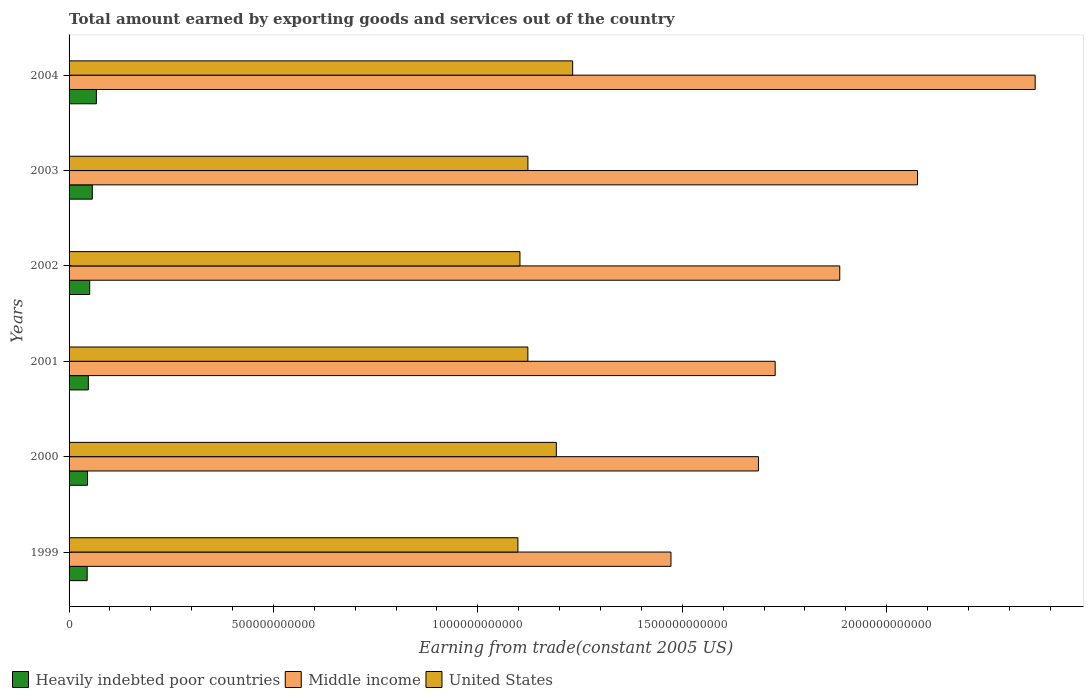How many different coloured bars are there?
Provide a short and direct response. 3. Are the number of bars on each tick of the Y-axis equal?
Your response must be concise. Yes. How many bars are there on the 3rd tick from the top?
Offer a terse response. 3. How many bars are there on the 6th tick from the bottom?
Keep it short and to the point. 3. In how many cases, is the number of bars for a given year not equal to the number of legend labels?
Ensure brevity in your answer.  0. What is the total amount earned by exporting goods and services in United States in 2003?
Your response must be concise. 1.12e+12. Across all years, what is the maximum total amount earned by exporting goods and services in Heavily indebted poor countries?
Offer a terse response. 6.68e+1. Across all years, what is the minimum total amount earned by exporting goods and services in Heavily indebted poor countries?
Provide a short and direct response. 4.43e+1. In which year was the total amount earned by exporting goods and services in Heavily indebted poor countries maximum?
Offer a very short reply. 2004. In which year was the total amount earned by exporting goods and services in Heavily indebted poor countries minimum?
Offer a very short reply. 1999. What is the total total amount earned by exporting goods and services in Heavily indebted poor countries in the graph?
Your response must be concise. 3.11e+11. What is the difference between the total amount earned by exporting goods and services in Heavily indebted poor countries in 1999 and that in 2002?
Keep it short and to the point. -6.18e+09. What is the difference between the total amount earned by exporting goods and services in Middle income in 1999 and the total amount earned by exporting goods and services in Heavily indebted poor countries in 2002?
Your response must be concise. 1.42e+12. What is the average total amount earned by exporting goods and services in Heavily indebted poor countries per year?
Make the answer very short. 5.18e+1. In the year 2000, what is the difference between the total amount earned by exporting goods and services in United States and total amount earned by exporting goods and services in Heavily indebted poor countries?
Offer a very short reply. 1.15e+12. In how many years, is the total amount earned by exporting goods and services in Middle income greater than 1400000000000 US$?
Ensure brevity in your answer.  6. What is the ratio of the total amount earned by exporting goods and services in United States in 1999 to that in 2003?
Offer a very short reply. 0.98. Is the total amount earned by exporting goods and services in Heavily indebted poor countries in 2000 less than that in 2001?
Provide a short and direct response. Yes. Is the difference between the total amount earned by exporting goods and services in United States in 2001 and 2004 greater than the difference between the total amount earned by exporting goods and services in Heavily indebted poor countries in 2001 and 2004?
Your answer should be compact. No. What is the difference between the highest and the second highest total amount earned by exporting goods and services in Heavily indebted poor countries?
Provide a succinct answer. 9.96e+09. What is the difference between the highest and the lowest total amount earned by exporting goods and services in Middle income?
Your answer should be very brief. 8.91e+11. Is the sum of the total amount earned by exporting goods and services in United States in 2000 and 2002 greater than the maximum total amount earned by exporting goods and services in Heavily indebted poor countries across all years?
Keep it short and to the point. Yes. What does the 3rd bar from the top in 2001 represents?
Provide a succinct answer. Heavily indebted poor countries. What does the 3rd bar from the bottom in 2003 represents?
Give a very brief answer. United States. How many bars are there?
Offer a terse response. 18. How many years are there in the graph?
Your answer should be very brief. 6. What is the difference between two consecutive major ticks on the X-axis?
Provide a succinct answer. 5.00e+11. Where does the legend appear in the graph?
Make the answer very short. Bottom left. How are the legend labels stacked?
Your answer should be compact. Horizontal. What is the title of the graph?
Ensure brevity in your answer.  Total amount earned by exporting goods and services out of the country. Does "Northern Mariana Islands" appear as one of the legend labels in the graph?
Provide a short and direct response. No. What is the label or title of the X-axis?
Give a very brief answer. Earning from trade(constant 2005 US). What is the Earning from trade(constant 2005 US) of Heavily indebted poor countries in 1999?
Your answer should be very brief. 4.43e+1. What is the Earning from trade(constant 2005 US) of Middle income in 1999?
Your answer should be very brief. 1.47e+12. What is the Earning from trade(constant 2005 US) of United States in 1999?
Give a very brief answer. 1.10e+12. What is the Earning from trade(constant 2005 US) of Heavily indebted poor countries in 2000?
Give a very brief answer. 4.51e+1. What is the Earning from trade(constant 2005 US) of Middle income in 2000?
Make the answer very short. 1.69e+12. What is the Earning from trade(constant 2005 US) in United States in 2000?
Keep it short and to the point. 1.19e+12. What is the Earning from trade(constant 2005 US) in Heavily indebted poor countries in 2001?
Your answer should be compact. 4.71e+1. What is the Earning from trade(constant 2005 US) of Middle income in 2001?
Your answer should be very brief. 1.73e+12. What is the Earning from trade(constant 2005 US) of United States in 2001?
Offer a terse response. 1.12e+12. What is the Earning from trade(constant 2005 US) in Heavily indebted poor countries in 2002?
Provide a succinct answer. 5.05e+1. What is the Earning from trade(constant 2005 US) of Middle income in 2002?
Make the answer very short. 1.89e+12. What is the Earning from trade(constant 2005 US) of United States in 2002?
Provide a succinct answer. 1.10e+12. What is the Earning from trade(constant 2005 US) in Heavily indebted poor countries in 2003?
Your answer should be compact. 5.68e+1. What is the Earning from trade(constant 2005 US) of Middle income in 2003?
Offer a very short reply. 2.08e+12. What is the Earning from trade(constant 2005 US) in United States in 2003?
Ensure brevity in your answer.  1.12e+12. What is the Earning from trade(constant 2005 US) of Heavily indebted poor countries in 2004?
Offer a terse response. 6.68e+1. What is the Earning from trade(constant 2005 US) in Middle income in 2004?
Provide a short and direct response. 2.36e+12. What is the Earning from trade(constant 2005 US) in United States in 2004?
Provide a short and direct response. 1.23e+12. Across all years, what is the maximum Earning from trade(constant 2005 US) of Heavily indebted poor countries?
Give a very brief answer. 6.68e+1. Across all years, what is the maximum Earning from trade(constant 2005 US) in Middle income?
Your response must be concise. 2.36e+12. Across all years, what is the maximum Earning from trade(constant 2005 US) of United States?
Offer a terse response. 1.23e+12. Across all years, what is the minimum Earning from trade(constant 2005 US) of Heavily indebted poor countries?
Your response must be concise. 4.43e+1. Across all years, what is the minimum Earning from trade(constant 2005 US) of Middle income?
Your answer should be very brief. 1.47e+12. Across all years, what is the minimum Earning from trade(constant 2005 US) of United States?
Provide a short and direct response. 1.10e+12. What is the total Earning from trade(constant 2005 US) of Heavily indebted poor countries in the graph?
Ensure brevity in your answer.  3.11e+11. What is the total Earning from trade(constant 2005 US) in Middle income in the graph?
Offer a very short reply. 1.12e+13. What is the total Earning from trade(constant 2005 US) of United States in the graph?
Your response must be concise. 6.87e+12. What is the difference between the Earning from trade(constant 2005 US) of Heavily indebted poor countries in 1999 and that in 2000?
Your response must be concise. -7.91e+08. What is the difference between the Earning from trade(constant 2005 US) of Middle income in 1999 and that in 2000?
Offer a terse response. -2.14e+11. What is the difference between the Earning from trade(constant 2005 US) of United States in 1999 and that in 2000?
Make the answer very short. -9.40e+1. What is the difference between the Earning from trade(constant 2005 US) of Heavily indebted poor countries in 1999 and that in 2001?
Your answer should be compact. -2.83e+09. What is the difference between the Earning from trade(constant 2005 US) of Middle income in 1999 and that in 2001?
Provide a short and direct response. -2.55e+11. What is the difference between the Earning from trade(constant 2005 US) of United States in 1999 and that in 2001?
Provide a succinct answer. -2.44e+1. What is the difference between the Earning from trade(constant 2005 US) in Heavily indebted poor countries in 1999 and that in 2002?
Keep it short and to the point. -6.18e+09. What is the difference between the Earning from trade(constant 2005 US) of Middle income in 1999 and that in 2002?
Your answer should be compact. -4.13e+11. What is the difference between the Earning from trade(constant 2005 US) in United States in 1999 and that in 2002?
Provide a short and direct response. -5.04e+09. What is the difference between the Earning from trade(constant 2005 US) in Heavily indebted poor countries in 1999 and that in 2003?
Offer a terse response. -1.25e+1. What is the difference between the Earning from trade(constant 2005 US) in Middle income in 1999 and that in 2003?
Keep it short and to the point. -6.03e+11. What is the difference between the Earning from trade(constant 2005 US) in United States in 1999 and that in 2003?
Ensure brevity in your answer.  -2.45e+1. What is the difference between the Earning from trade(constant 2005 US) of Heavily indebted poor countries in 1999 and that in 2004?
Your response must be concise. -2.25e+1. What is the difference between the Earning from trade(constant 2005 US) of Middle income in 1999 and that in 2004?
Your answer should be compact. -8.91e+11. What is the difference between the Earning from trade(constant 2005 US) in United States in 1999 and that in 2004?
Keep it short and to the point. -1.34e+11. What is the difference between the Earning from trade(constant 2005 US) in Heavily indebted poor countries in 2000 and that in 2001?
Make the answer very short. -2.04e+09. What is the difference between the Earning from trade(constant 2005 US) of Middle income in 2000 and that in 2001?
Provide a succinct answer. -4.09e+1. What is the difference between the Earning from trade(constant 2005 US) of United States in 2000 and that in 2001?
Ensure brevity in your answer.  6.96e+1. What is the difference between the Earning from trade(constant 2005 US) in Heavily indebted poor countries in 2000 and that in 2002?
Provide a short and direct response. -5.38e+09. What is the difference between the Earning from trade(constant 2005 US) of Middle income in 2000 and that in 2002?
Offer a very short reply. -1.99e+11. What is the difference between the Earning from trade(constant 2005 US) of United States in 2000 and that in 2002?
Your answer should be compact. 8.90e+1. What is the difference between the Earning from trade(constant 2005 US) of Heavily indebted poor countries in 2000 and that in 2003?
Give a very brief answer. -1.17e+1. What is the difference between the Earning from trade(constant 2005 US) in Middle income in 2000 and that in 2003?
Provide a short and direct response. -3.89e+11. What is the difference between the Earning from trade(constant 2005 US) of United States in 2000 and that in 2003?
Offer a very short reply. 6.95e+1. What is the difference between the Earning from trade(constant 2005 US) of Heavily indebted poor countries in 2000 and that in 2004?
Your response must be concise. -2.17e+1. What is the difference between the Earning from trade(constant 2005 US) of Middle income in 2000 and that in 2004?
Make the answer very short. -6.77e+11. What is the difference between the Earning from trade(constant 2005 US) of United States in 2000 and that in 2004?
Ensure brevity in your answer.  -3.99e+1. What is the difference between the Earning from trade(constant 2005 US) in Heavily indebted poor countries in 2001 and that in 2002?
Your response must be concise. -3.34e+09. What is the difference between the Earning from trade(constant 2005 US) in Middle income in 2001 and that in 2002?
Your response must be concise. -1.58e+11. What is the difference between the Earning from trade(constant 2005 US) of United States in 2001 and that in 2002?
Offer a terse response. 1.94e+1. What is the difference between the Earning from trade(constant 2005 US) in Heavily indebted poor countries in 2001 and that in 2003?
Provide a short and direct response. -9.70e+09. What is the difference between the Earning from trade(constant 2005 US) of Middle income in 2001 and that in 2003?
Your answer should be very brief. -3.48e+11. What is the difference between the Earning from trade(constant 2005 US) of United States in 2001 and that in 2003?
Make the answer very short. -1.06e+08. What is the difference between the Earning from trade(constant 2005 US) in Heavily indebted poor countries in 2001 and that in 2004?
Your response must be concise. -1.97e+1. What is the difference between the Earning from trade(constant 2005 US) of Middle income in 2001 and that in 2004?
Offer a very short reply. -6.36e+11. What is the difference between the Earning from trade(constant 2005 US) in United States in 2001 and that in 2004?
Your response must be concise. -1.10e+11. What is the difference between the Earning from trade(constant 2005 US) of Heavily indebted poor countries in 2002 and that in 2003?
Keep it short and to the point. -6.36e+09. What is the difference between the Earning from trade(constant 2005 US) of Middle income in 2002 and that in 2003?
Your response must be concise. -1.90e+11. What is the difference between the Earning from trade(constant 2005 US) of United States in 2002 and that in 2003?
Ensure brevity in your answer.  -1.95e+1. What is the difference between the Earning from trade(constant 2005 US) of Heavily indebted poor countries in 2002 and that in 2004?
Give a very brief answer. -1.63e+1. What is the difference between the Earning from trade(constant 2005 US) in Middle income in 2002 and that in 2004?
Offer a very short reply. -4.78e+11. What is the difference between the Earning from trade(constant 2005 US) of United States in 2002 and that in 2004?
Ensure brevity in your answer.  -1.29e+11. What is the difference between the Earning from trade(constant 2005 US) in Heavily indebted poor countries in 2003 and that in 2004?
Give a very brief answer. -9.96e+09. What is the difference between the Earning from trade(constant 2005 US) of Middle income in 2003 and that in 2004?
Keep it short and to the point. -2.88e+11. What is the difference between the Earning from trade(constant 2005 US) in United States in 2003 and that in 2004?
Your answer should be very brief. -1.09e+11. What is the difference between the Earning from trade(constant 2005 US) in Heavily indebted poor countries in 1999 and the Earning from trade(constant 2005 US) in Middle income in 2000?
Offer a terse response. -1.64e+12. What is the difference between the Earning from trade(constant 2005 US) in Heavily indebted poor countries in 1999 and the Earning from trade(constant 2005 US) in United States in 2000?
Make the answer very short. -1.15e+12. What is the difference between the Earning from trade(constant 2005 US) of Middle income in 1999 and the Earning from trade(constant 2005 US) of United States in 2000?
Offer a terse response. 2.80e+11. What is the difference between the Earning from trade(constant 2005 US) in Heavily indebted poor countries in 1999 and the Earning from trade(constant 2005 US) in Middle income in 2001?
Give a very brief answer. -1.68e+12. What is the difference between the Earning from trade(constant 2005 US) in Heavily indebted poor countries in 1999 and the Earning from trade(constant 2005 US) in United States in 2001?
Provide a short and direct response. -1.08e+12. What is the difference between the Earning from trade(constant 2005 US) of Middle income in 1999 and the Earning from trade(constant 2005 US) of United States in 2001?
Offer a terse response. 3.50e+11. What is the difference between the Earning from trade(constant 2005 US) in Heavily indebted poor countries in 1999 and the Earning from trade(constant 2005 US) in Middle income in 2002?
Give a very brief answer. -1.84e+12. What is the difference between the Earning from trade(constant 2005 US) in Heavily indebted poor countries in 1999 and the Earning from trade(constant 2005 US) in United States in 2002?
Provide a succinct answer. -1.06e+12. What is the difference between the Earning from trade(constant 2005 US) in Middle income in 1999 and the Earning from trade(constant 2005 US) in United States in 2002?
Your response must be concise. 3.69e+11. What is the difference between the Earning from trade(constant 2005 US) in Heavily indebted poor countries in 1999 and the Earning from trade(constant 2005 US) in Middle income in 2003?
Give a very brief answer. -2.03e+12. What is the difference between the Earning from trade(constant 2005 US) in Heavily indebted poor countries in 1999 and the Earning from trade(constant 2005 US) in United States in 2003?
Offer a very short reply. -1.08e+12. What is the difference between the Earning from trade(constant 2005 US) in Middle income in 1999 and the Earning from trade(constant 2005 US) in United States in 2003?
Keep it short and to the point. 3.50e+11. What is the difference between the Earning from trade(constant 2005 US) in Heavily indebted poor countries in 1999 and the Earning from trade(constant 2005 US) in Middle income in 2004?
Your response must be concise. -2.32e+12. What is the difference between the Earning from trade(constant 2005 US) of Heavily indebted poor countries in 1999 and the Earning from trade(constant 2005 US) of United States in 2004?
Make the answer very short. -1.19e+12. What is the difference between the Earning from trade(constant 2005 US) in Middle income in 1999 and the Earning from trade(constant 2005 US) in United States in 2004?
Provide a succinct answer. 2.40e+11. What is the difference between the Earning from trade(constant 2005 US) in Heavily indebted poor countries in 2000 and the Earning from trade(constant 2005 US) in Middle income in 2001?
Ensure brevity in your answer.  -1.68e+12. What is the difference between the Earning from trade(constant 2005 US) of Heavily indebted poor countries in 2000 and the Earning from trade(constant 2005 US) of United States in 2001?
Your answer should be compact. -1.08e+12. What is the difference between the Earning from trade(constant 2005 US) of Middle income in 2000 and the Earning from trade(constant 2005 US) of United States in 2001?
Ensure brevity in your answer.  5.64e+11. What is the difference between the Earning from trade(constant 2005 US) of Heavily indebted poor countries in 2000 and the Earning from trade(constant 2005 US) of Middle income in 2002?
Your response must be concise. -1.84e+12. What is the difference between the Earning from trade(constant 2005 US) in Heavily indebted poor countries in 2000 and the Earning from trade(constant 2005 US) in United States in 2002?
Ensure brevity in your answer.  -1.06e+12. What is the difference between the Earning from trade(constant 2005 US) of Middle income in 2000 and the Earning from trade(constant 2005 US) of United States in 2002?
Provide a succinct answer. 5.83e+11. What is the difference between the Earning from trade(constant 2005 US) in Heavily indebted poor countries in 2000 and the Earning from trade(constant 2005 US) in Middle income in 2003?
Make the answer very short. -2.03e+12. What is the difference between the Earning from trade(constant 2005 US) of Heavily indebted poor countries in 2000 and the Earning from trade(constant 2005 US) of United States in 2003?
Provide a succinct answer. -1.08e+12. What is the difference between the Earning from trade(constant 2005 US) of Middle income in 2000 and the Earning from trade(constant 2005 US) of United States in 2003?
Keep it short and to the point. 5.64e+11. What is the difference between the Earning from trade(constant 2005 US) of Heavily indebted poor countries in 2000 and the Earning from trade(constant 2005 US) of Middle income in 2004?
Ensure brevity in your answer.  -2.32e+12. What is the difference between the Earning from trade(constant 2005 US) of Heavily indebted poor countries in 2000 and the Earning from trade(constant 2005 US) of United States in 2004?
Make the answer very short. -1.19e+12. What is the difference between the Earning from trade(constant 2005 US) in Middle income in 2000 and the Earning from trade(constant 2005 US) in United States in 2004?
Offer a terse response. 4.55e+11. What is the difference between the Earning from trade(constant 2005 US) of Heavily indebted poor countries in 2001 and the Earning from trade(constant 2005 US) of Middle income in 2002?
Make the answer very short. -1.84e+12. What is the difference between the Earning from trade(constant 2005 US) in Heavily indebted poor countries in 2001 and the Earning from trade(constant 2005 US) in United States in 2002?
Your answer should be very brief. -1.06e+12. What is the difference between the Earning from trade(constant 2005 US) of Middle income in 2001 and the Earning from trade(constant 2005 US) of United States in 2002?
Your answer should be very brief. 6.24e+11. What is the difference between the Earning from trade(constant 2005 US) of Heavily indebted poor countries in 2001 and the Earning from trade(constant 2005 US) of Middle income in 2003?
Ensure brevity in your answer.  -2.03e+12. What is the difference between the Earning from trade(constant 2005 US) of Heavily indebted poor countries in 2001 and the Earning from trade(constant 2005 US) of United States in 2003?
Ensure brevity in your answer.  -1.08e+12. What is the difference between the Earning from trade(constant 2005 US) of Middle income in 2001 and the Earning from trade(constant 2005 US) of United States in 2003?
Provide a succinct answer. 6.05e+11. What is the difference between the Earning from trade(constant 2005 US) in Heavily indebted poor countries in 2001 and the Earning from trade(constant 2005 US) in Middle income in 2004?
Keep it short and to the point. -2.32e+12. What is the difference between the Earning from trade(constant 2005 US) in Heavily indebted poor countries in 2001 and the Earning from trade(constant 2005 US) in United States in 2004?
Offer a terse response. -1.18e+12. What is the difference between the Earning from trade(constant 2005 US) of Middle income in 2001 and the Earning from trade(constant 2005 US) of United States in 2004?
Give a very brief answer. 4.95e+11. What is the difference between the Earning from trade(constant 2005 US) of Heavily indebted poor countries in 2002 and the Earning from trade(constant 2005 US) of Middle income in 2003?
Keep it short and to the point. -2.03e+12. What is the difference between the Earning from trade(constant 2005 US) of Heavily indebted poor countries in 2002 and the Earning from trade(constant 2005 US) of United States in 2003?
Provide a succinct answer. -1.07e+12. What is the difference between the Earning from trade(constant 2005 US) of Middle income in 2002 and the Earning from trade(constant 2005 US) of United States in 2003?
Provide a short and direct response. 7.63e+11. What is the difference between the Earning from trade(constant 2005 US) in Heavily indebted poor countries in 2002 and the Earning from trade(constant 2005 US) in Middle income in 2004?
Give a very brief answer. -2.31e+12. What is the difference between the Earning from trade(constant 2005 US) of Heavily indebted poor countries in 2002 and the Earning from trade(constant 2005 US) of United States in 2004?
Offer a terse response. -1.18e+12. What is the difference between the Earning from trade(constant 2005 US) in Middle income in 2002 and the Earning from trade(constant 2005 US) in United States in 2004?
Keep it short and to the point. 6.53e+11. What is the difference between the Earning from trade(constant 2005 US) of Heavily indebted poor countries in 2003 and the Earning from trade(constant 2005 US) of Middle income in 2004?
Provide a short and direct response. -2.31e+12. What is the difference between the Earning from trade(constant 2005 US) of Heavily indebted poor countries in 2003 and the Earning from trade(constant 2005 US) of United States in 2004?
Offer a terse response. -1.18e+12. What is the difference between the Earning from trade(constant 2005 US) of Middle income in 2003 and the Earning from trade(constant 2005 US) of United States in 2004?
Offer a terse response. 8.44e+11. What is the average Earning from trade(constant 2005 US) of Heavily indebted poor countries per year?
Your answer should be compact. 5.18e+1. What is the average Earning from trade(constant 2005 US) of Middle income per year?
Your answer should be very brief. 1.87e+12. What is the average Earning from trade(constant 2005 US) in United States per year?
Offer a very short reply. 1.14e+12. In the year 1999, what is the difference between the Earning from trade(constant 2005 US) of Heavily indebted poor countries and Earning from trade(constant 2005 US) of Middle income?
Give a very brief answer. -1.43e+12. In the year 1999, what is the difference between the Earning from trade(constant 2005 US) of Heavily indebted poor countries and Earning from trade(constant 2005 US) of United States?
Provide a succinct answer. -1.05e+12. In the year 1999, what is the difference between the Earning from trade(constant 2005 US) in Middle income and Earning from trade(constant 2005 US) in United States?
Your answer should be compact. 3.74e+11. In the year 2000, what is the difference between the Earning from trade(constant 2005 US) of Heavily indebted poor countries and Earning from trade(constant 2005 US) of Middle income?
Offer a very short reply. -1.64e+12. In the year 2000, what is the difference between the Earning from trade(constant 2005 US) of Heavily indebted poor countries and Earning from trade(constant 2005 US) of United States?
Provide a short and direct response. -1.15e+12. In the year 2000, what is the difference between the Earning from trade(constant 2005 US) in Middle income and Earning from trade(constant 2005 US) in United States?
Provide a short and direct response. 4.94e+11. In the year 2001, what is the difference between the Earning from trade(constant 2005 US) of Heavily indebted poor countries and Earning from trade(constant 2005 US) of Middle income?
Give a very brief answer. -1.68e+12. In the year 2001, what is the difference between the Earning from trade(constant 2005 US) of Heavily indebted poor countries and Earning from trade(constant 2005 US) of United States?
Make the answer very short. -1.08e+12. In the year 2001, what is the difference between the Earning from trade(constant 2005 US) of Middle income and Earning from trade(constant 2005 US) of United States?
Offer a terse response. 6.05e+11. In the year 2002, what is the difference between the Earning from trade(constant 2005 US) of Heavily indebted poor countries and Earning from trade(constant 2005 US) of Middle income?
Offer a terse response. -1.83e+12. In the year 2002, what is the difference between the Earning from trade(constant 2005 US) in Heavily indebted poor countries and Earning from trade(constant 2005 US) in United States?
Ensure brevity in your answer.  -1.05e+12. In the year 2002, what is the difference between the Earning from trade(constant 2005 US) of Middle income and Earning from trade(constant 2005 US) of United States?
Make the answer very short. 7.82e+11. In the year 2003, what is the difference between the Earning from trade(constant 2005 US) in Heavily indebted poor countries and Earning from trade(constant 2005 US) in Middle income?
Make the answer very short. -2.02e+12. In the year 2003, what is the difference between the Earning from trade(constant 2005 US) of Heavily indebted poor countries and Earning from trade(constant 2005 US) of United States?
Ensure brevity in your answer.  -1.07e+12. In the year 2003, what is the difference between the Earning from trade(constant 2005 US) in Middle income and Earning from trade(constant 2005 US) in United States?
Make the answer very short. 9.53e+11. In the year 2004, what is the difference between the Earning from trade(constant 2005 US) of Heavily indebted poor countries and Earning from trade(constant 2005 US) of Middle income?
Offer a very short reply. -2.30e+12. In the year 2004, what is the difference between the Earning from trade(constant 2005 US) of Heavily indebted poor countries and Earning from trade(constant 2005 US) of United States?
Provide a short and direct response. -1.17e+12. In the year 2004, what is the difference between the Earning from trade(constant 2005 US) in Middle income and Earning from trade(constant 2005 US) in United States?
Make the answer very short. 1.13e+12. What is the ratio of the Earning from trade(constant 2005 US) in Heavily indebted poor countries in 1999 to that in 2000?
Offer a very short reply. 0.98. What is the ratio of the Earning from trade(constant 2005 US) in Middle income in 1999 to that in 2000?
Offer a very short reply. 0.87. What is the ratio of the Earning from trade(constant 2005 US) of United States in 1999 to that in 2000?
Give a very brief answer. 0.92. What is the ratio of the Earning from trade(constant 2005 US) of Heavily indebted poor countries in 1999 to that in 2001?
Give a very brief answer. 0.94. What is the ratio of the Earning from trade(constant 2005 US) in Middle income in 1999 to that in 2001?
Offer a terse response. 0.85. What is the ratio of the Earning from trade(constant 2005 US) of United States in 1999 to that in 2001?
Keep it short and to the point. 0.98. What is the ratio of the Earning from trade(constant 2005 US) of Heavily indebted poor countries in 1999 to that in 2002?
Offer a very short reply. 0.88. What is the ratio of the Earning from trade(constant 2005 US) of Middle income in 1999 to that in 2002?
Offer a terse response. 0.78. What is the ratio of the Earning from trade(constant 2005 US) of United States in 1999 to that in 2002?
Offer a terse response. 1. What is the ratio of the Earning from trade(constant 2005 US) in Heavily indebted poor countries in 1999 to that in 2003?
Offer a terse response. 0.78. What is the ratio of the Earning from trade(constant 2005 US) in Middle income in 1999 to that in 2003?
Keep it short and to the point. 0.71. What is the ratio of the Earning from trade(constant 2005 US) in United States in 1999 to that in 2003?
Keep it short and to the point. 0.98. What is the ratio of the Earning from trade(constant 2005 US) of Heavily indebted poor countries in 1999 to that in 2004?
Your answer should be compact. 0.66. What is the ratio of the Earning from trade(constant 2005 US) in Middle income in 1999 to that in 2004?
Make the answer very short. 0.62. What is the ratio of the Earning from trade(constant 2005 US) in United States in 1999 to that in 2004?
Ensure brevity in your answer.  0.89. What is the ratio of the Earning from trade(constant 2005 US) in Heavily indebted poor countries in 2000 to that in 2001?
Keep it short and to the point. 0.96. What is the ratio of the Earning from trade(constant 2005 US) of Middle income in 2000 to that in 2001?
Offer a very short reply. 0.98. What is the ratio of the Earning from trade(constant 2005 US) of United States in 2000 to that in 2001?
Make the answer very short. 1.06. What is the ratio of the Earning from trade(constant 2005 US) in Heavily indebted poor countries in 2000 to that in 2002?
Offer a terse response. 0.89. What is the ratio of the Earning from trade(constant 2005 US) in Middle income in 2000 to that in 2002?
Provide a succinct answer. 0.89. What is the ratio of the Earning from trade(constant 2005 US) of United States in 2000 to that in 2002?
Give a very brief answer. 1.08. What is the ratio of the Earning from trade(constant 2005 US) in Heavily indebted poor countries in 2000 to that in 2003?
Provide a short and direct response. 0.79. What is the ratio of the Earning from trade(constant 2005 US) in Middle income in 2000 to that in 2003?
Provide a succinct answer. 0.81. What is the ratio of the Earning from trade(constant 2005 US) of United States in 2000 to that in 2003?
Offer a terse response. 1.06. What is the ratio of the Earning from trade(constant 2005 US) in Heavily indebted poor countries in 2000 to that in 2004?
Your response must be concise. 0.68. What is the ratio of the Earning from trade(constant 2005 US) in Middle income in 2000 to that in 2004?
Your response must be concise. 0.71. What is the ratio of the Earning from trade(constant 2005 US) of United States in 2000 to that in 2004?
Provide a succinct answer. 0.97. What is the ratio of the Earning from trade(constant 2005 US) in Heavily indebted poor countries in 2001 to that in 2002?
Give a very brief answer. 0.93. What is the ratio of the Earning from trade(constant 2005 US) of Middle income in 2001 to that in 2002?
Ensure brevity in your answer.  0.92. What is the ratio of the Earning from trade(constant 2005 US) in United States in 2001 to that in 2002?
Your answer should be very brief. 1.02. What is the ratio of the Earning from trade(constant 2005 US) of Heavily indebted poor countries in 2001 to that in 2003?
Give a very brief answer. 0.83. What is the ratio of the Earning from trade(constant 2005 US) of Middle income in 2001 to that in 2003?
Ensure brevity in your answer.  0.83. What is the ratio of the Earning from trade(constant 2005 US) of Heavily indebted poor countries in 2001 to that in 2004?
Ensure brevity in your answer.  0.71. What is the ratio of the Earning from trade(constant 2005 US) of Middle income in 2001 to that in 2004?
Provide a short and direct response. 0.73. What is the ratio of the Earning from trade(constant 2005 US) in United States in 2001 to that in 2004?
Your response must be concise. 0.91. What is the ratio of the Earning from trade(constant 2005 US) in Heavily indebted poor countries in 2002 to that in 2003?
Offer a terse response. 0.89. What is the ratio of the Earning from trade(constant 2005 US) of Middle income in 2002 to that in 2003?
Offer a terse response. 0.91. What is the ratio of the Earning from trade(constant 2005 US) in United States in 2002 to that in 2003?
Offer a terse response. 0.98. What is the ratio of the Earning from trade(constant 2005 US) of Heavily indebted poor countries in 2002 to that in 2004?
Keep it short and to the point. 0.76. What is the ratio of the Earning from trade(constant 2005 US) of Middle income in 2002 to that in 2004?
Keep it short and to the point. 0.8. What is the ratio of the Earning from trade(constant 2005 US) in United States in 2002 to that in 2004?
Provide a short and direct response. 0.9. What is the ratio of the Earning from trade(constant 2005 US) in Heavily indebted poor countries in 2003 to that in 2004?
Provide a succinct answer. 0.85. What is the ratio of the Earning from trade(constant 2005 US) of Middle income in 2003 to that in 2004?
Ensure brevity in your answer.  0.88. What is the ratio of the Earning from trade(constant 2005 US) of United States in 2003 to that in 2004?
Ensure brevity in your answer.  0.91. What is the difference between the highest and the second highest Earning from trade(constant 2005 US) of Heavily indebted poor countries?
Offer a very short reply. 9.96e+09. What is the difference between the highest and the second highest Earning from trade(constant 2005 US) in Middle income?
Offer a terse response. 2.88e+11. What is the difference between the highest and the second highest Earning from trade(constant 2005 US) in United States?
Your answer should be very brief. 3.99e+1. What is the difference between the highest and the lowest Earning from trade(constant 2005 US) in Heavily indebted poor countries?
Provide a short and direct response. 2.25e+1. What is the difference between the highest and the lowest Earning from trade(constant 2005 US) in Middle income?
Ensure brevity in your answer.  8.91e+11. What is the difference between the highest and the lowest Earning from trade(constant 2005 US) in United States?
Your answer should be very brief. 1.34e+11. 